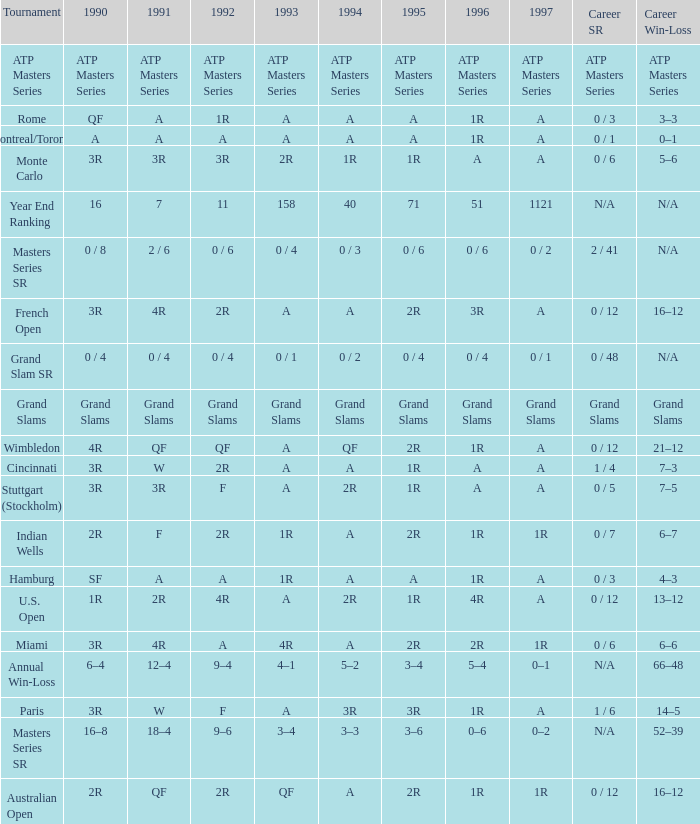What is 1997, when 1996 is "1R", when 1990 is "2R", and when 1991 is "F"? 1R. 